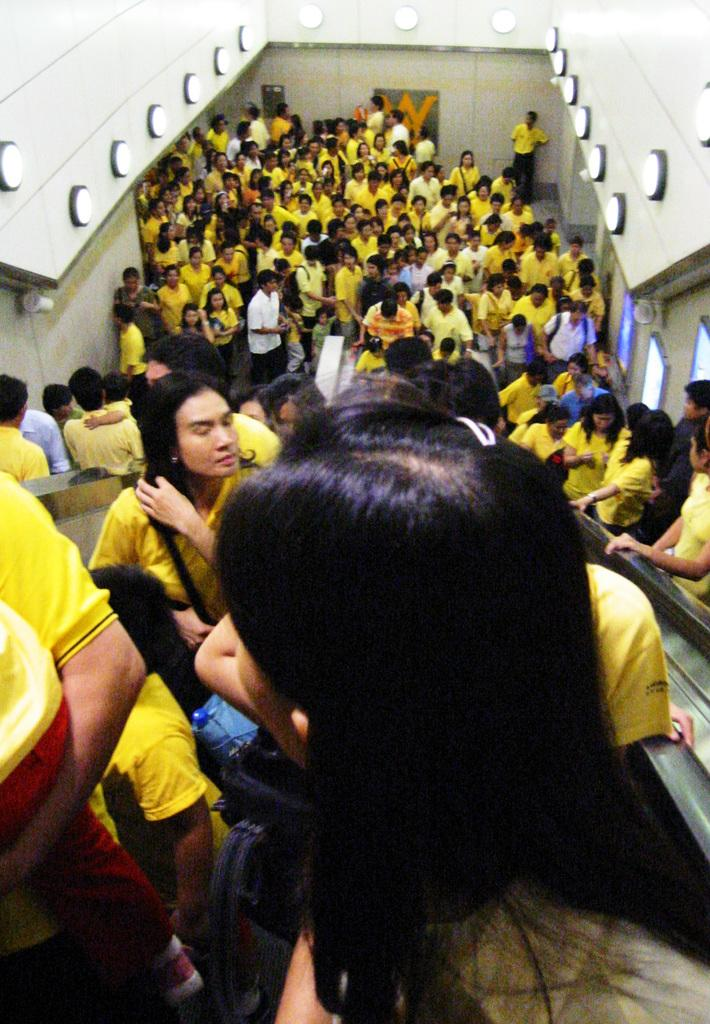How many people are in the image? There are many people in the image. What are some of the people in the image doing? Some people are standing on an escalator. What type of decision can be seen being made by the flag in the image? There is no flag present in the image, so it is not possible to determine what decision might be made by a flag. 